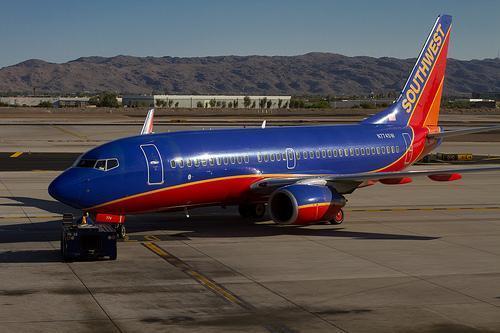How many planes on the landing?
Give a very brief answer. 1. 